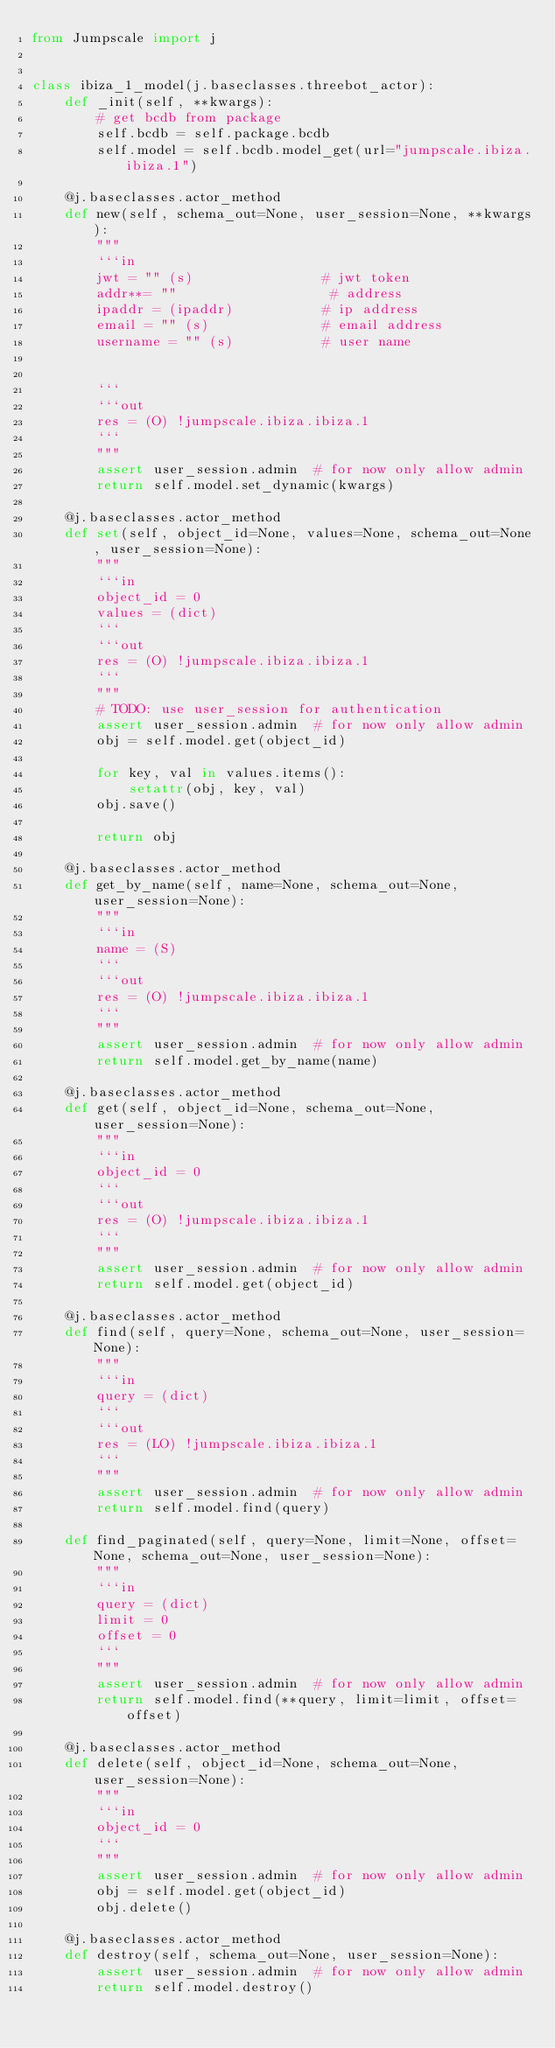<code> <loc_0><loc_0><loc_500><loc_500><_Python_>from Jumpscale import j


class ibiza_1_model(j.baseclasses.threebot_actor):
    def _init(self, **kwargs):
        # get bcdb from package
        self.bcdb = self.package.bcdb
        self.model = self.bcdb.model_get(url="jumpscale.ibiza.ibiza.1")

    @j.baseclasses.actor_method
    def new(self, schema_out=None, user_session=None, **kwargs):
        """
        ```in
        jwt = "" (s)                # jwt token
        addr**= ""                   # address
        ipaddr = (ipaddr)           # ip address
        email = "" (s)              # email address
        username = "" (s)           # user name


        ```
        ```out
        res = (O) !jumpscale.ibiza.ibiza.1
        ```
        """
        assert user_session.admin  # for now only allow admin
        return self.model.set_dynamic(kwargs)

    @j.baseclasses.actor_method
    def set(self, object_id=None, values=None, schema_out=None, user_session=None):
        """
        ```in
        object_id = 0
        values = (dict)
        ```
        ```out
        res = (O) !jumpscale.ibiza.ibiza.1
        ```
        """
        # TODO: use user_session for authentication
        assert user_session.admin  # for now only allow admin
        obj = self.model.get(object_id)

        for key, val in values.items():
            setattr(obj, key, val)
        obj.save()

        return obj

    @j.baseclasses.actor_method
    def get_by_name(self, name=None, schema_out=None, user_session=None):
        """
        ```in
        name = (S)
        ```
        ```out
        res = (O) !jumpscale.ibiza.ibiza.1
        ```
        """
        assert user_session.admin  # for now only allow admin
        return self.model.get_by_name(name)

    @j.baseclasses.actor_method
    def get(self, object_id=None, schema_out=None, user_session=None):
        """
        ```in
        object_id = 0
        ```
        ```out
        res = (O) !jumpscale.ibiza.ibiza.1
        ```
        """
        assert user_session.admin  # for now only allow admin
        return self.model.get(object_id)

    @j.baseclasses.actor_method
    def find(self, query=None, schema_out=None, user_session=None):
        """
        ```in
        query = (dict)
        ```
        ```out
        res = (LO) !jumpscale.ibiza.ibiza.1
        ```
        """
        assert user_session.admin  # for now only allow admin
        return self.model.find(query)

    def find_paginated(self, query=None, limit=None, offset=None, schema_out=None, user_session=None):
        """
        ```in
        query = (dict)
        limit = 0
        offset = 0
        ```
        """
        assert user_session.admin  # for now only allow admin
        return self.model.find(**query, limit=limit, offset=offset)

    @j.baseclasses.actor_method
    def delete(self, object_id=None, schema_out=None, user_session=None):
        """
        ```in
        object_id = 0
        ```
        """
        assert user_session.admin  # for now only allow admin
        obj = self.model.get(object_id)
        obj.delete()

    @j.baseclasses.actor_method
    def destroy(self, schema_out=None, user_session=None):
        assert user_session.admin  # for now only allow admin
        return self.model.destroy()
</code> 